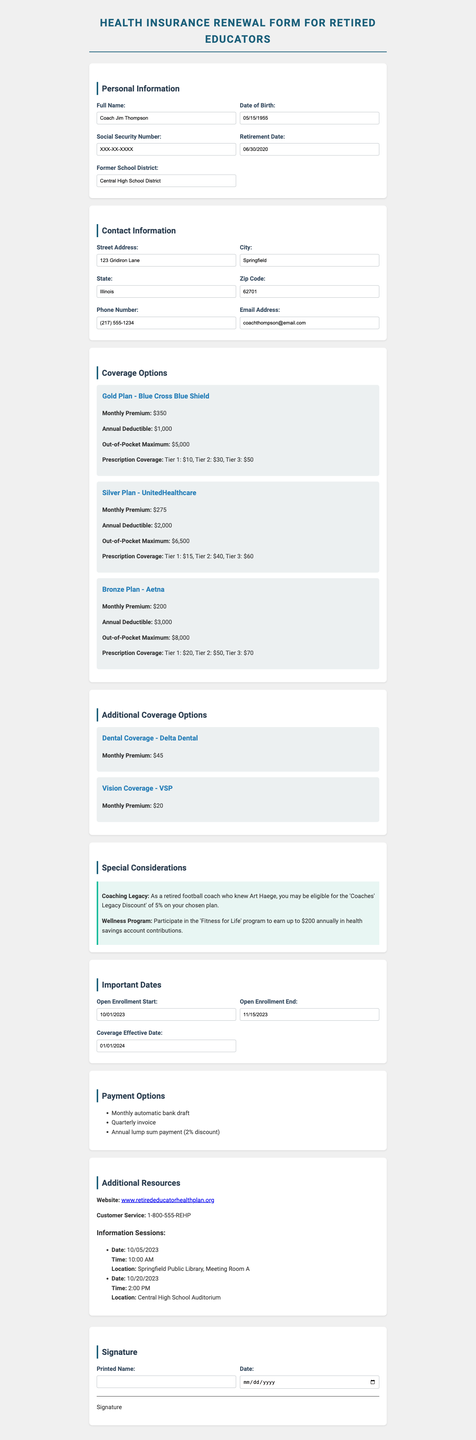what is the name of the insurance provider for the Gold Plan? The Gold Plan is provided by Blue Cross Blue Shield as stated in the coverage options section.
Answer: Blue Cross Blue Shield what is the monthly premium for the Silver Plan? The monthly premium for the Silver Plan is listed in the coverage options section as $275.
Answer: $275 when does the open enrollment period start? The open enrollment period start date is mentioned in the important dates section as 10/01/2023.
Answer: 10/01/2023 what discount may retired coaches be eligible for? The document states that retired coaches may be eligible for the 'Coaches' Legacy Discount' of 5%.
Answer: 5% how much is the annual deductible for the Bronze Plan? The annual deductible for the Bronze Plan is specified in the coverage options as $3,000.
Answer: $3,000 what is the effective date for the coverage? The effective date for coverage is mentioned in the important dates section as 01/01/2024.
Answer: 01/01/2024 how much is the monthly premium for Vision Coverage? The monthly premium for Vision Coverage is included in the additional coverage options as $20.
Answer: $20 how many information sessions are scheduled? The document lists two information sessions under additional resources.
Answer: 2 what is the address listed for the contact information? The address provided in the contact information is included as 123 Gridiron Lane, Springfield, Illinois, 62701.
Answer: 123 Gridiron Lane 